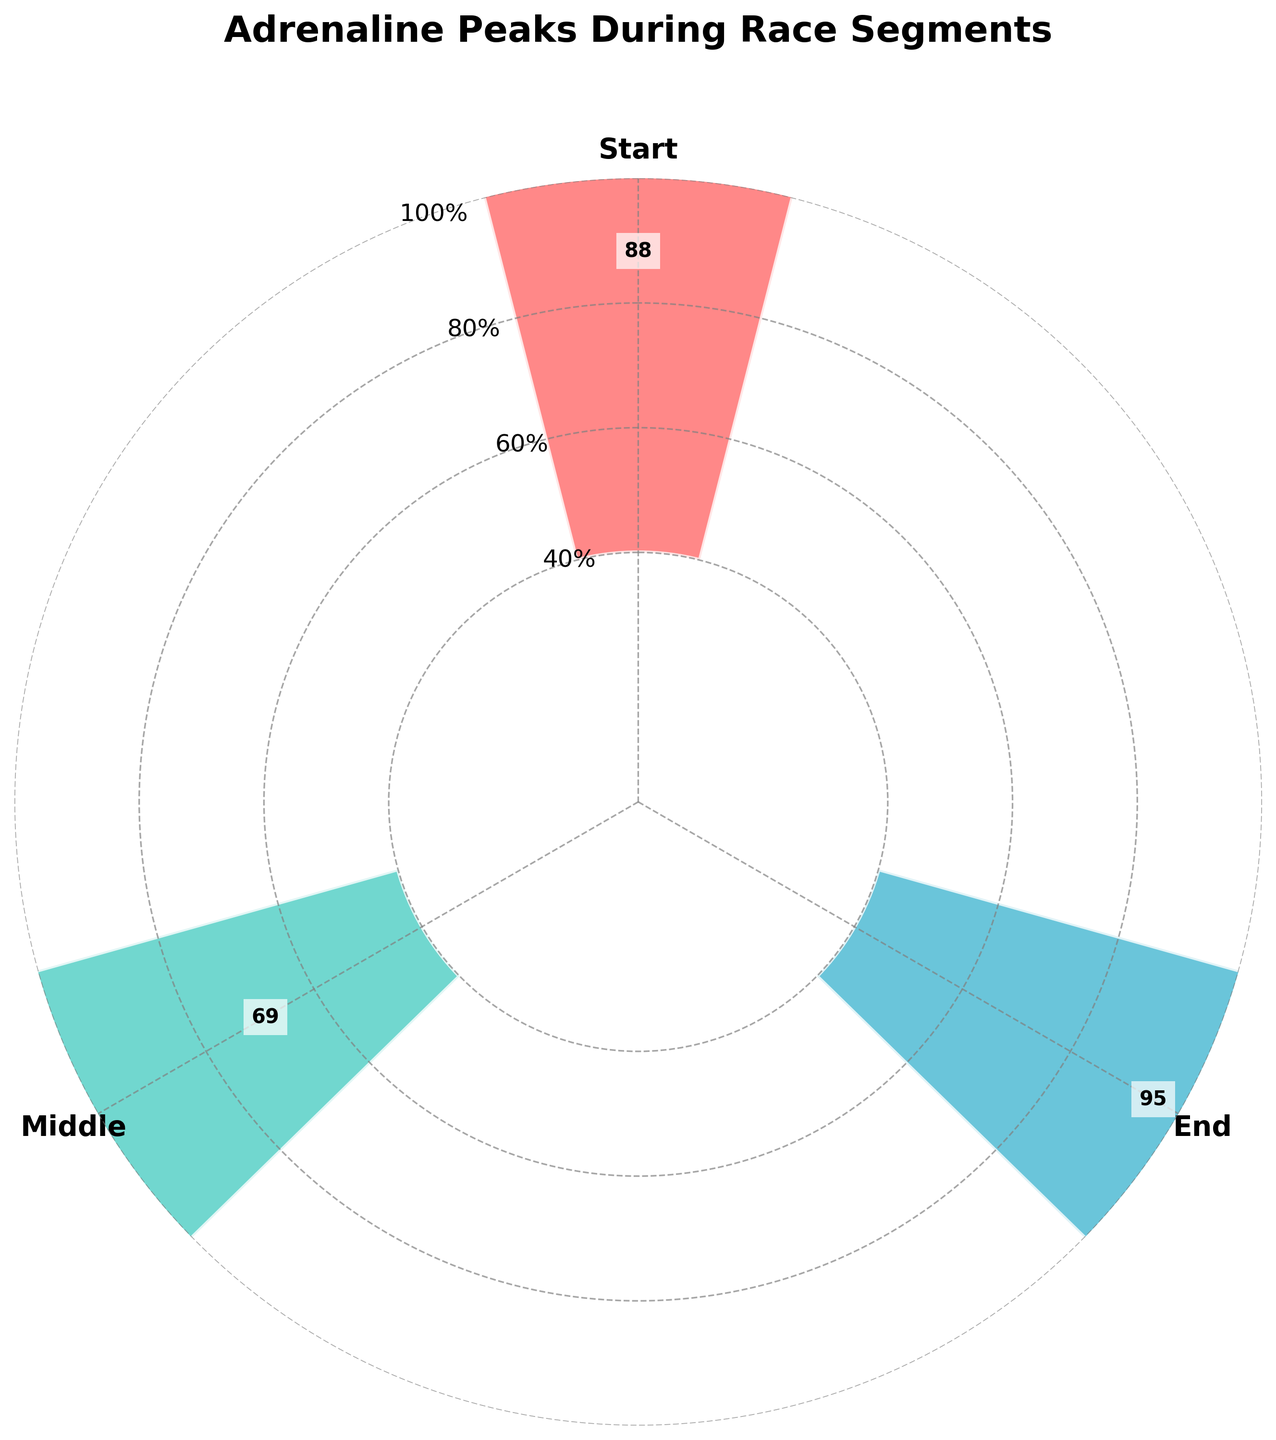What is the title of the plot? The title is displayed at the top of the plot, and it provides the main idea or the subject. The title "Adrenaline Peaks During Race Segments" indicates that the plot is about the frequency of adrenaline peaks in different segments of a race.
Answer: Adrenaline Peaks During Race Segments How many segments are shown in the plot? The segments are indicated by the labels around the plot, which show discrete point names. By counting these labels, we find three segments are shown.
Answer: Three segments Which color represents the 'End' segment? By referring to the colored bars in the plot and the labeled segments, you can identify the color associated with the 'End' segment. It is the last in the sequence. The 'End' segment is represented by a shade of blue.
Answer: Blue What is the average frequency of adrenaline peaks in the 'Middle' segment? The frequency values for the segments are shown as bars, with numerical labels on them. The 'Middle' segment has bars representing frequencies around 70, 65, and 72. The average can be calculated as (70 + 65 + 72) / 3 = 69.
Answer: 69 Which segment has the highest frequency of adrenaline peaks? By comparing the heights of the bars in different segments, the 'End' segment reaches the highest frequencies, shown by the tallest bars.
Answer: End Compare the frequencies of 'Start' and 'Middle' segments. Which one is higher? Average frequencies for both segments can be compared directly. The 'Start' segment shows values around 85, 92, and 88, while the 'Middle' segment has values around 70, 65, and 72. Calculating the averages, the 'Start' segment is higher with (85 + 92 + 88) / 3 = 88.33 compared to the 'Middle' segment's 69.
Answer: Start What is the median frequency value in the 'Start' segment? For the 'Start' segment, the values are 85, 92, and 88. To find the median, first, order these values (85, 88, 92). The middle value is 88.
Answer: 88 Determine the range of frequencies in the 'End' segment. The frequencies in the 'End' segment are 95, 98, and 93. The range is found by subtracting the smallest value from the largest value: 98 - 93 = 5.
Answer: 5 What is the relative difference in frequencies between 'Start' and 'End' segments? Calculate the average for both segments first. The 'Start' segment average is (85 + 92 + 88) / 3 = 88.33, and the 'End' segment average is (95 + 98 + 93) / 3 = 95.33. The relative difference is ((95.33 - 88.33) / 88.33) * 100 ≈ 7.94%.
Answer: 7.94% How do the frequency values change from 'Middle' to 'End' segments? By looking at the bars in the plot, one can see the shift from the 'Middle' to 'End' segment. The 'Middle' has frequencies around 70, 65, and 72; the 'End' frequencies are higher at 95, 98, and 93, indicating an increase.
Answer: Increase 